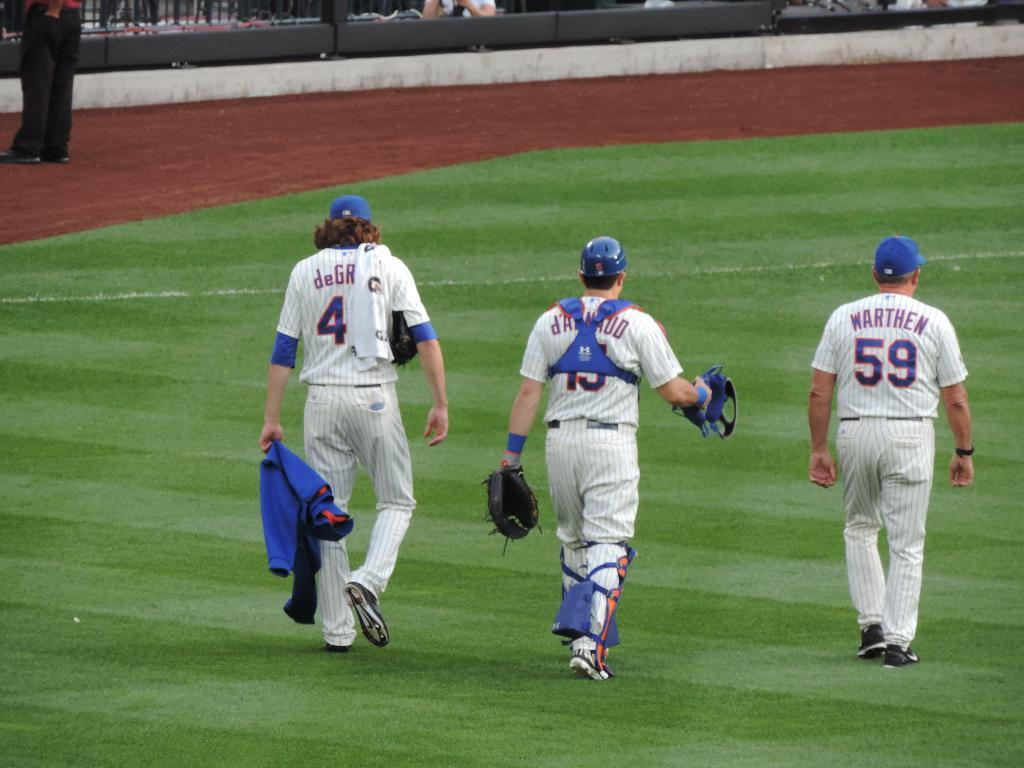<image>
Describe the image concisely. The player on the far right is number 59 Warthen. 